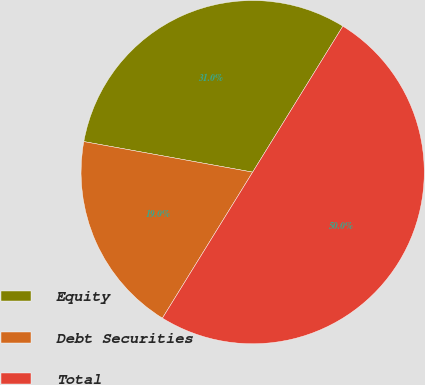Convert chart to OTSL. <chart><loc_0><loc_0><loc_500><loc_500><pie_chart><fcel>Equity<fcel>Debt Securities<fcel>Total<nl><fcel>30.96%<fcel>19.04%<fcel>50.0%<nl></chart> 